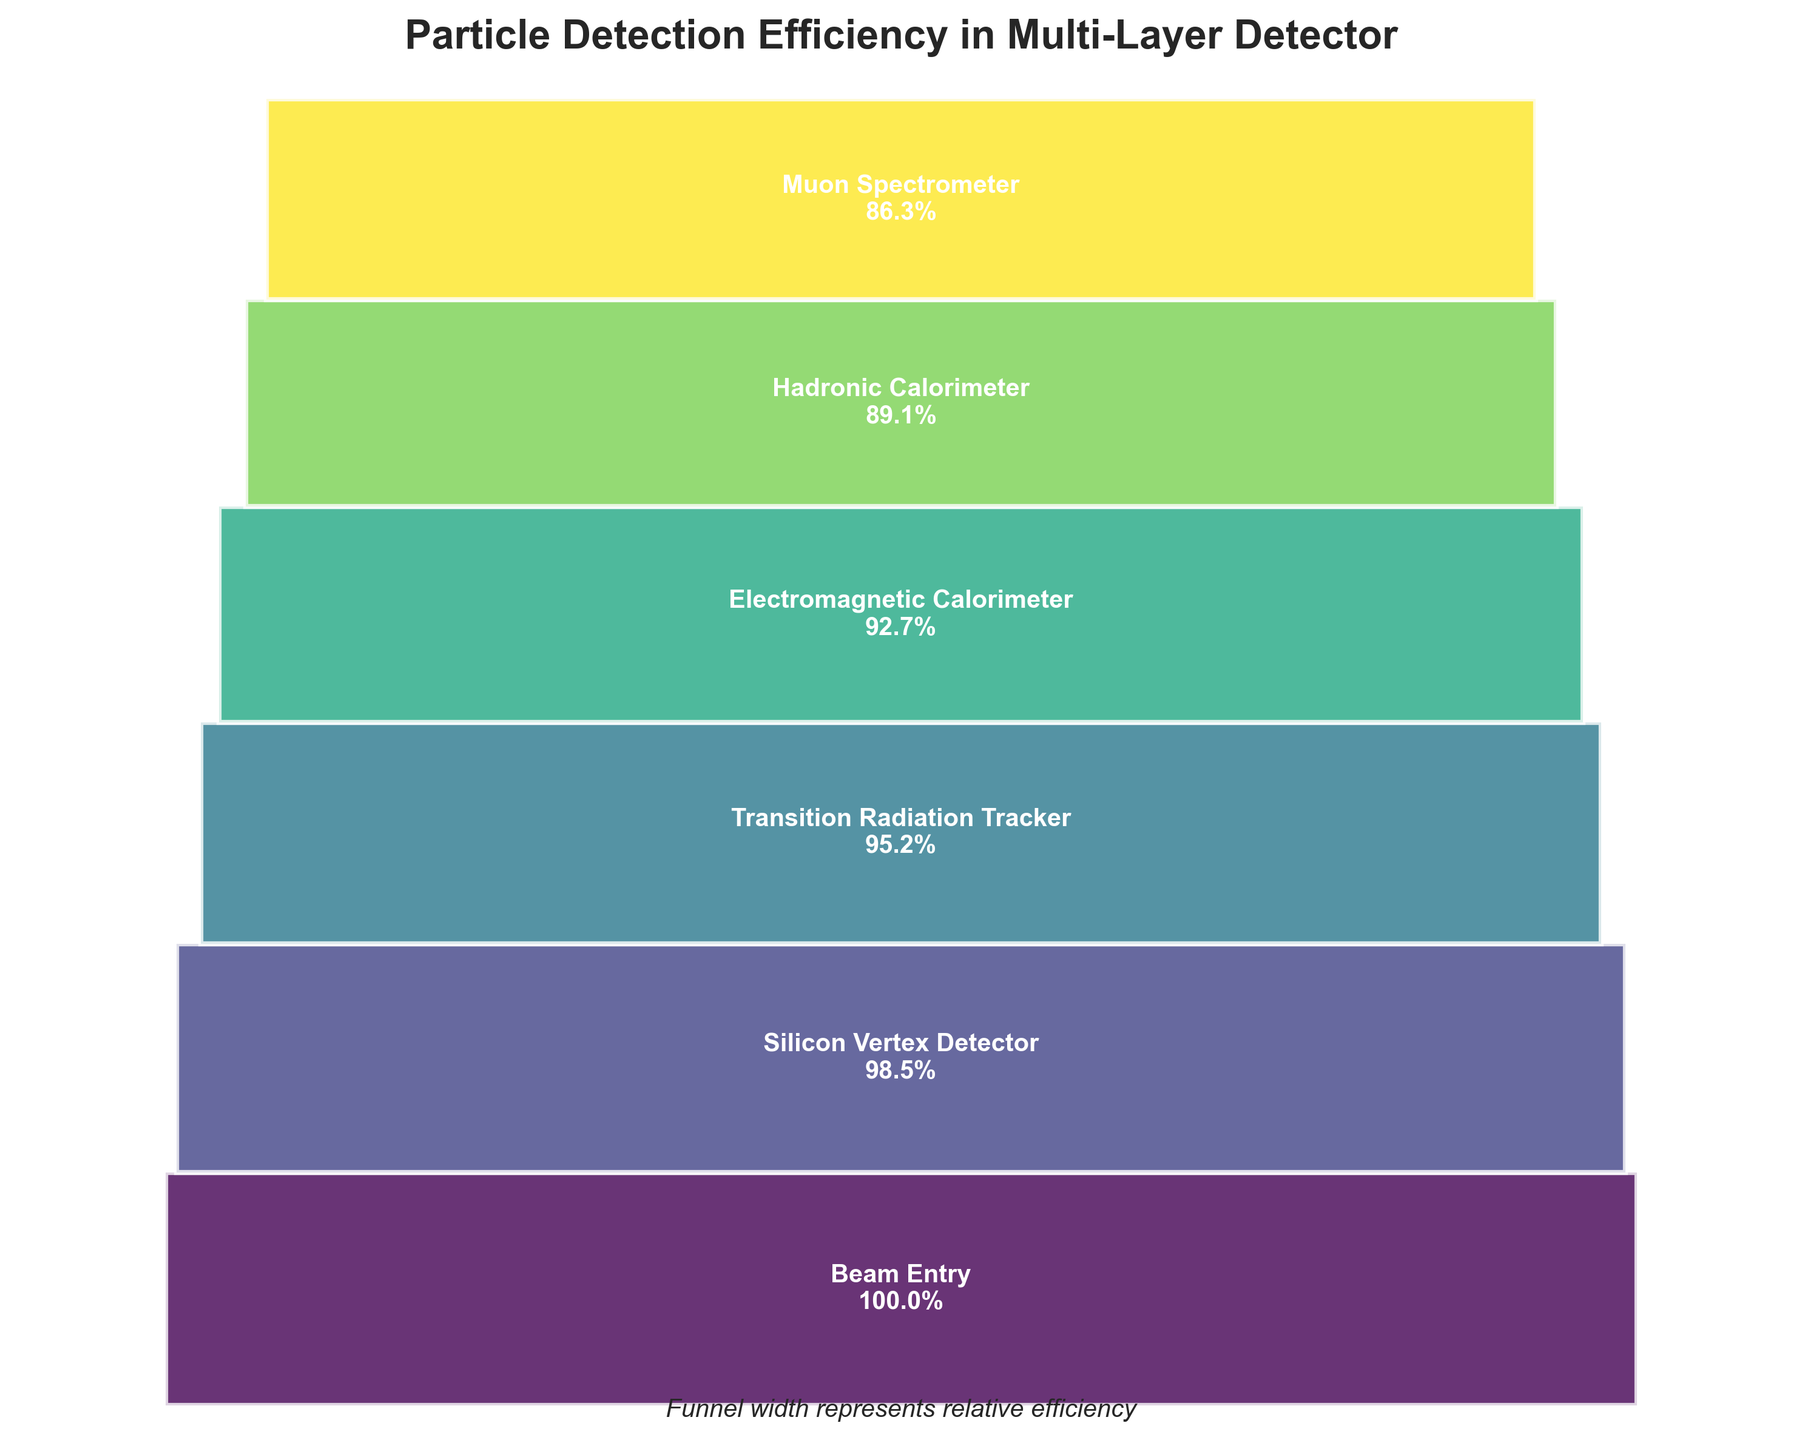what is the title of the figure? The title is typically at the top of the figure for better identification. In this case, the title is "Particle Detection Efficiency in Multi-Layer Detector," as indicated above the plot.
Answer: Particle Detection Efficiency in Multi-Layer Detector Which layer has the lowest particle detection efficiency? The lowest particle detection efficiency is identified by looking for the smallest percentage value in the funnel chart. The Muon Spectrometer has an efficiency of 86.3%, which is the lowest.
Answer: Muon Spectrometer How many layers are represented in the funnel chart? Each segment in the funnel chart corresponds to a layer. Counting the segments reveals that there are six layers.
Answer: 6 What is the efficiency difference between the Electromagnetic Calorimeter and the Silicon Vertex Detector? Subtracting the efficiency of the Electromagnetic Calorimeter (92.7%) from the Silicon Vertex Detector (98.5%) gives the difference: 98.5 - 92.7 = 5.8%.
Answer: 5.8% Which layer shows the first drop in particle detection efficiency? The first drop in the funnel chart occurs when there is a reduction in efficiency from one layer to the next. The first drop is from the Beam Entry (100%) to the Silicon Vertex Detector (98.5%).
Answer: Silicon Vertex Detector Is the particle detection efficiency higher in the Transition Radiation Tracker or the Hadronic Calorimeter? By comparing the efficiency values, the Transition Radiation Tracker has an efficiency of 95.2%, while the Hadronic Calorimeter has an efficiency of 89.1%, so the Transition Radiation Tracker is higher.
Answer: Transition Radiation Tracker What is the total efficiency loss from Beam Entry to Muon Spectrometer? The Beam Entry starts at 100%, and the Muon Spectrometer ends at 86.3%. The total efficiency loss is calculated as 100 - 86.3 = 13.7%.
Answer: 13.7% What is the approximate average efficiency across all layers? To find the average, first sum all efficiencies: 100% + 98.5% + 95.2% + 92.7% + 89.1% + 86.3% = 561.8%, then divide by the number of layers (six): 561.8 / 6 ≈ 93.6%.
Answer: 93.6% What does the width of each segment in the funnel represent? The width of each segment in the funnel chart corresponds to the relative efficiency of each layer compared to the highest efficiency layer. Hence, wider segments reflect higher efficiencies.
Answer: Relative efficiency 